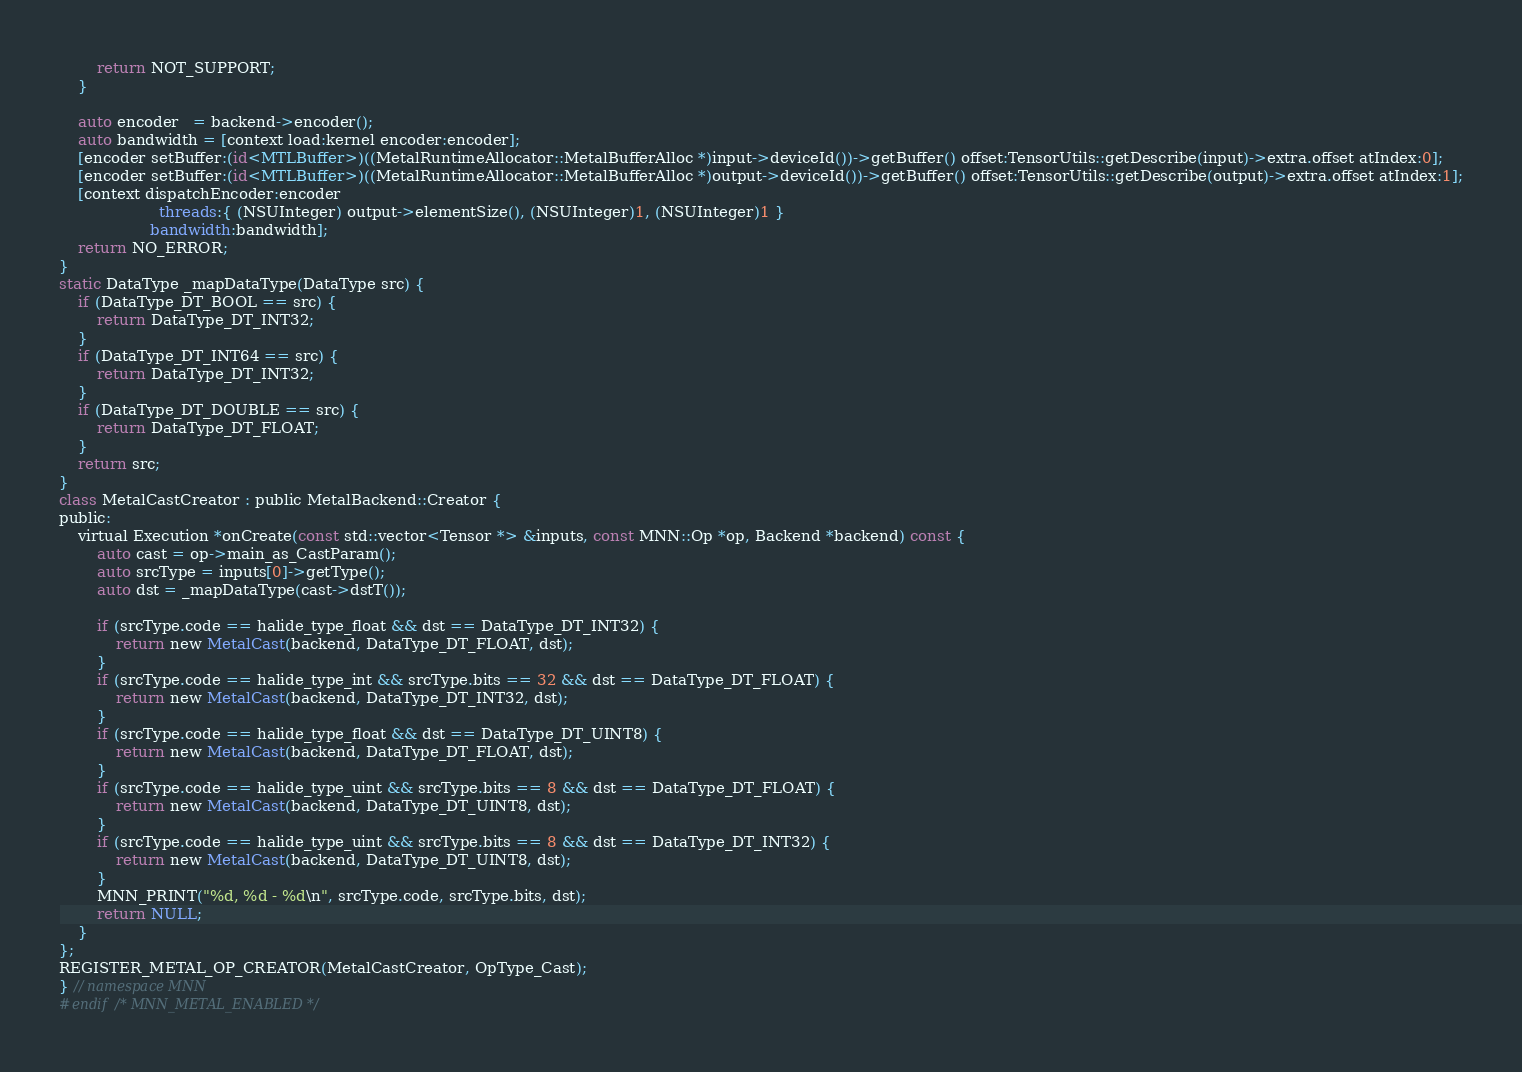<code> <loc_0><loc_0><loc_500><loc_500><_ObjectiveC_>        return NOT_SUPPORT;
    }

    auto encoder   = backend->encoder();
    auto bandwidth = [context load:kernel encoder:encoder];
    [encoder setBuffer:(id<MTLBuffer>)((MetalRuntimeAllocator::MetalBufferAlloc *)input->deviceId())->getBuffer() offset:TensorUtils::getDescribe(input)->extra.offset atIndex:0];
    [encoder setBuffer:(id<MTLBuffer>)((MetalRuntimeAllocator::MetalBufferAlloc *)output->deviceId())->getBuffer() offset:TensorUtils::getDescribe(output)->extra.offset atIndex:1];
    [context dispatchEncoder:encoder
                     threads:{ (NSUInteger) output->elementSize(), (NSUInteger)1, (NSUInteger)1 }
                   bandwidth:bandwidth];
    return NO_ERROR;
}
static DataType _mapDataType(DataType src) {
    if (DataType_DT_BOOL == src) {
        return DataType_DT_INT32;
    }
    if (DataType_DT_INT64 == src) {
        return DataType_DT_INT32;
    }
    if (DataType_DT_DOUBLE == src) {
        return DataType_DT_FLOAT;
    }
    return src;
}
class MetalCastCreator : public MetalBackend::Creator {
public:
    virtual Execution *onCreate(const std::vector<Tensor *> &inputs, const MNN::Op *op, Backend *backend) const {
        auto cast = op->main_as_CastParam();
        auto srcType = inputs[0]->getType();
        auto dst = _mapDataType(cast->dstT());

        if (srcType.code == halide_type_float && dst == DataType_DT_INT32) {
            return new MetalCast(backend, DataType_DT_FLOAT, dst);
        }
        if (srcType.code == halide_type_int && srcType.bits == 32 && dst == DataType_DT_FLOAT) {
            return new MetalCast(backend, DataType_DT_INT32, dst);
        }
        if (srcType.code == halide_type_float && dst == DataType_DT_UINT8) {
            return new MetalCast(backend, DataType_DT_FLOAT, dst);
        }
        if (srcType.code == halide_type_uint && srcType.bits == 8 && dst == DataType_DT_FLOAT) {
            return new MetalCast(backend, DataType_DT_UINT8, dst);
        }
        if (srcType.code == halide_type_uint && srcType.bits == 8 && dst == DataType_DT_INT32) {
            return new MetalCast(backend, DataType_DT_UINT8, dst);
        }
        MNN_PRINT("%d, %d - %d\n", srcType.code, srcType.bits, dst);
        return NULL;
    }
};
REGISTER_METAL_OP_CREATOR(MetalCastCreator, OpType_Cast);
} // namespace MNN
#endif /* MNN_METAL_ENABLED */
</code> 